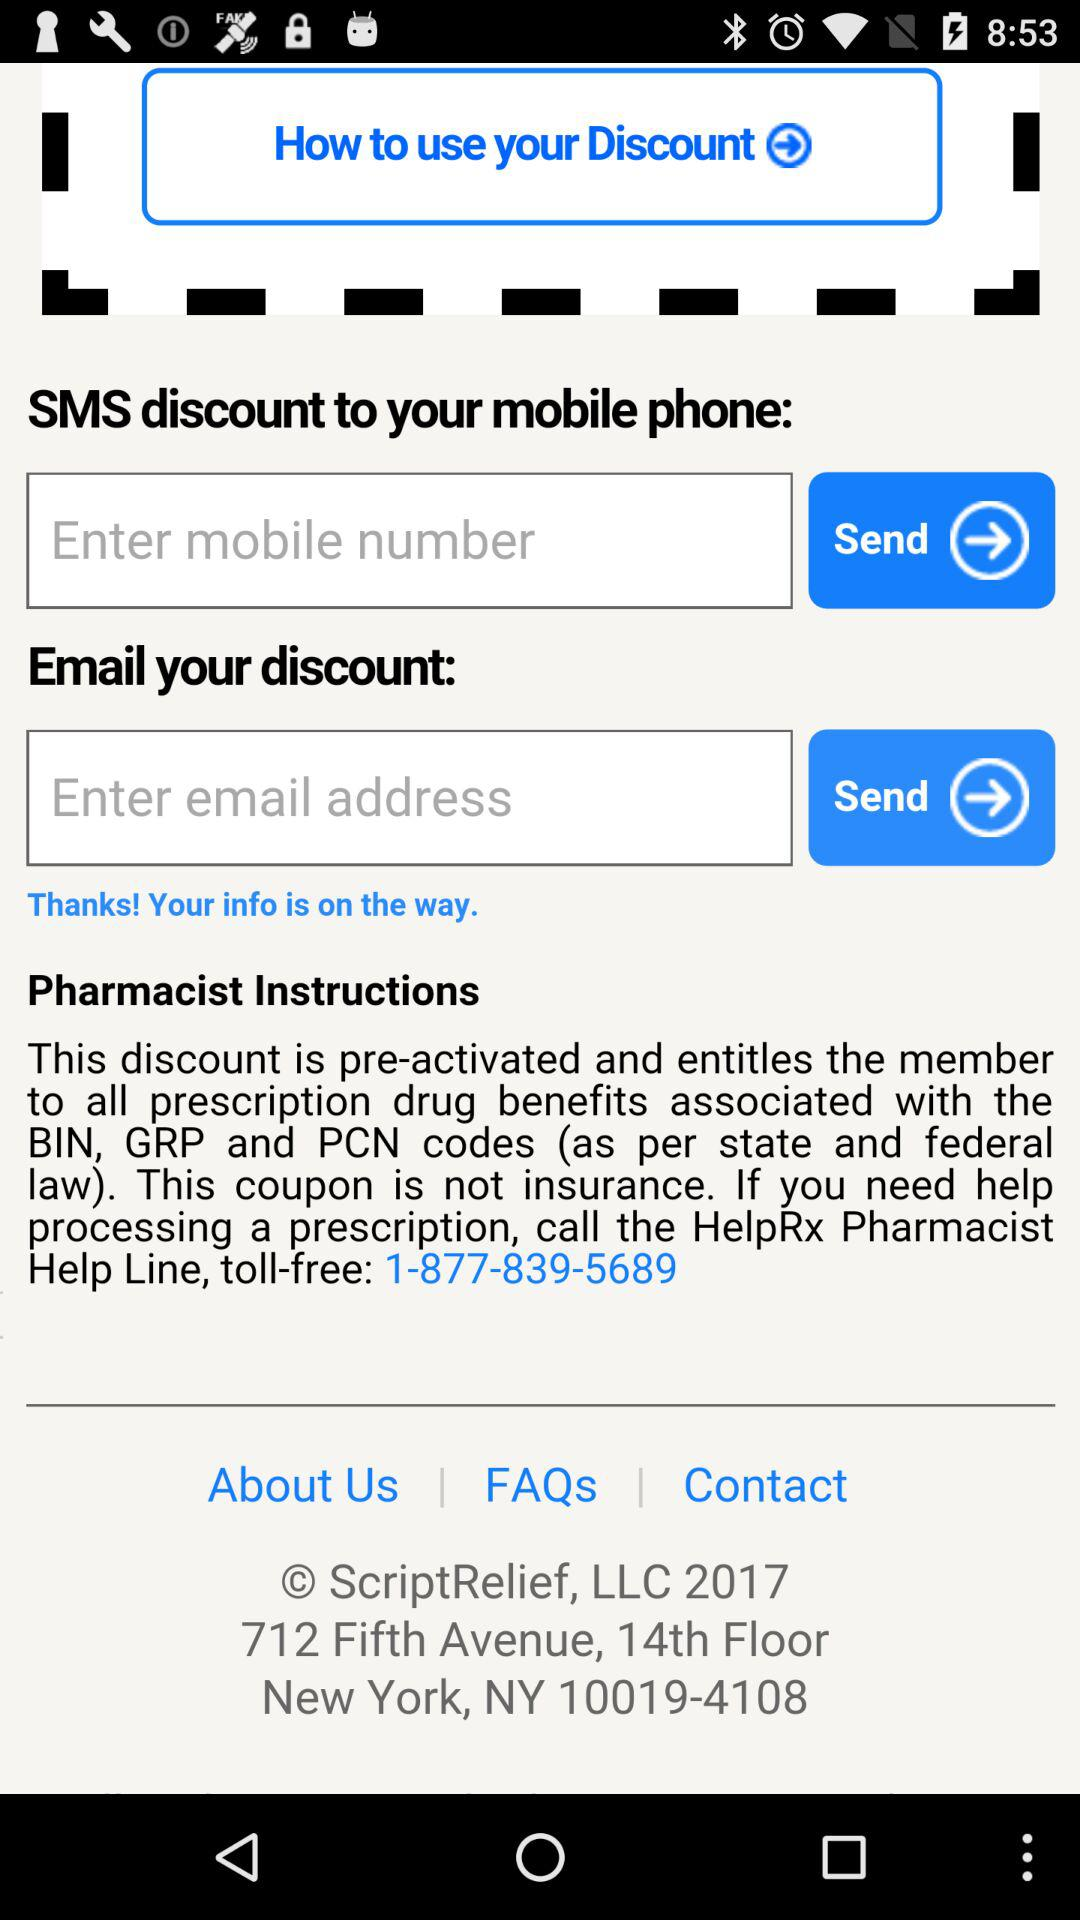What is the toll-free helpline number for the pharmacist? The toll-free helpline number for the pharmacist is 1-877-839-5689. 